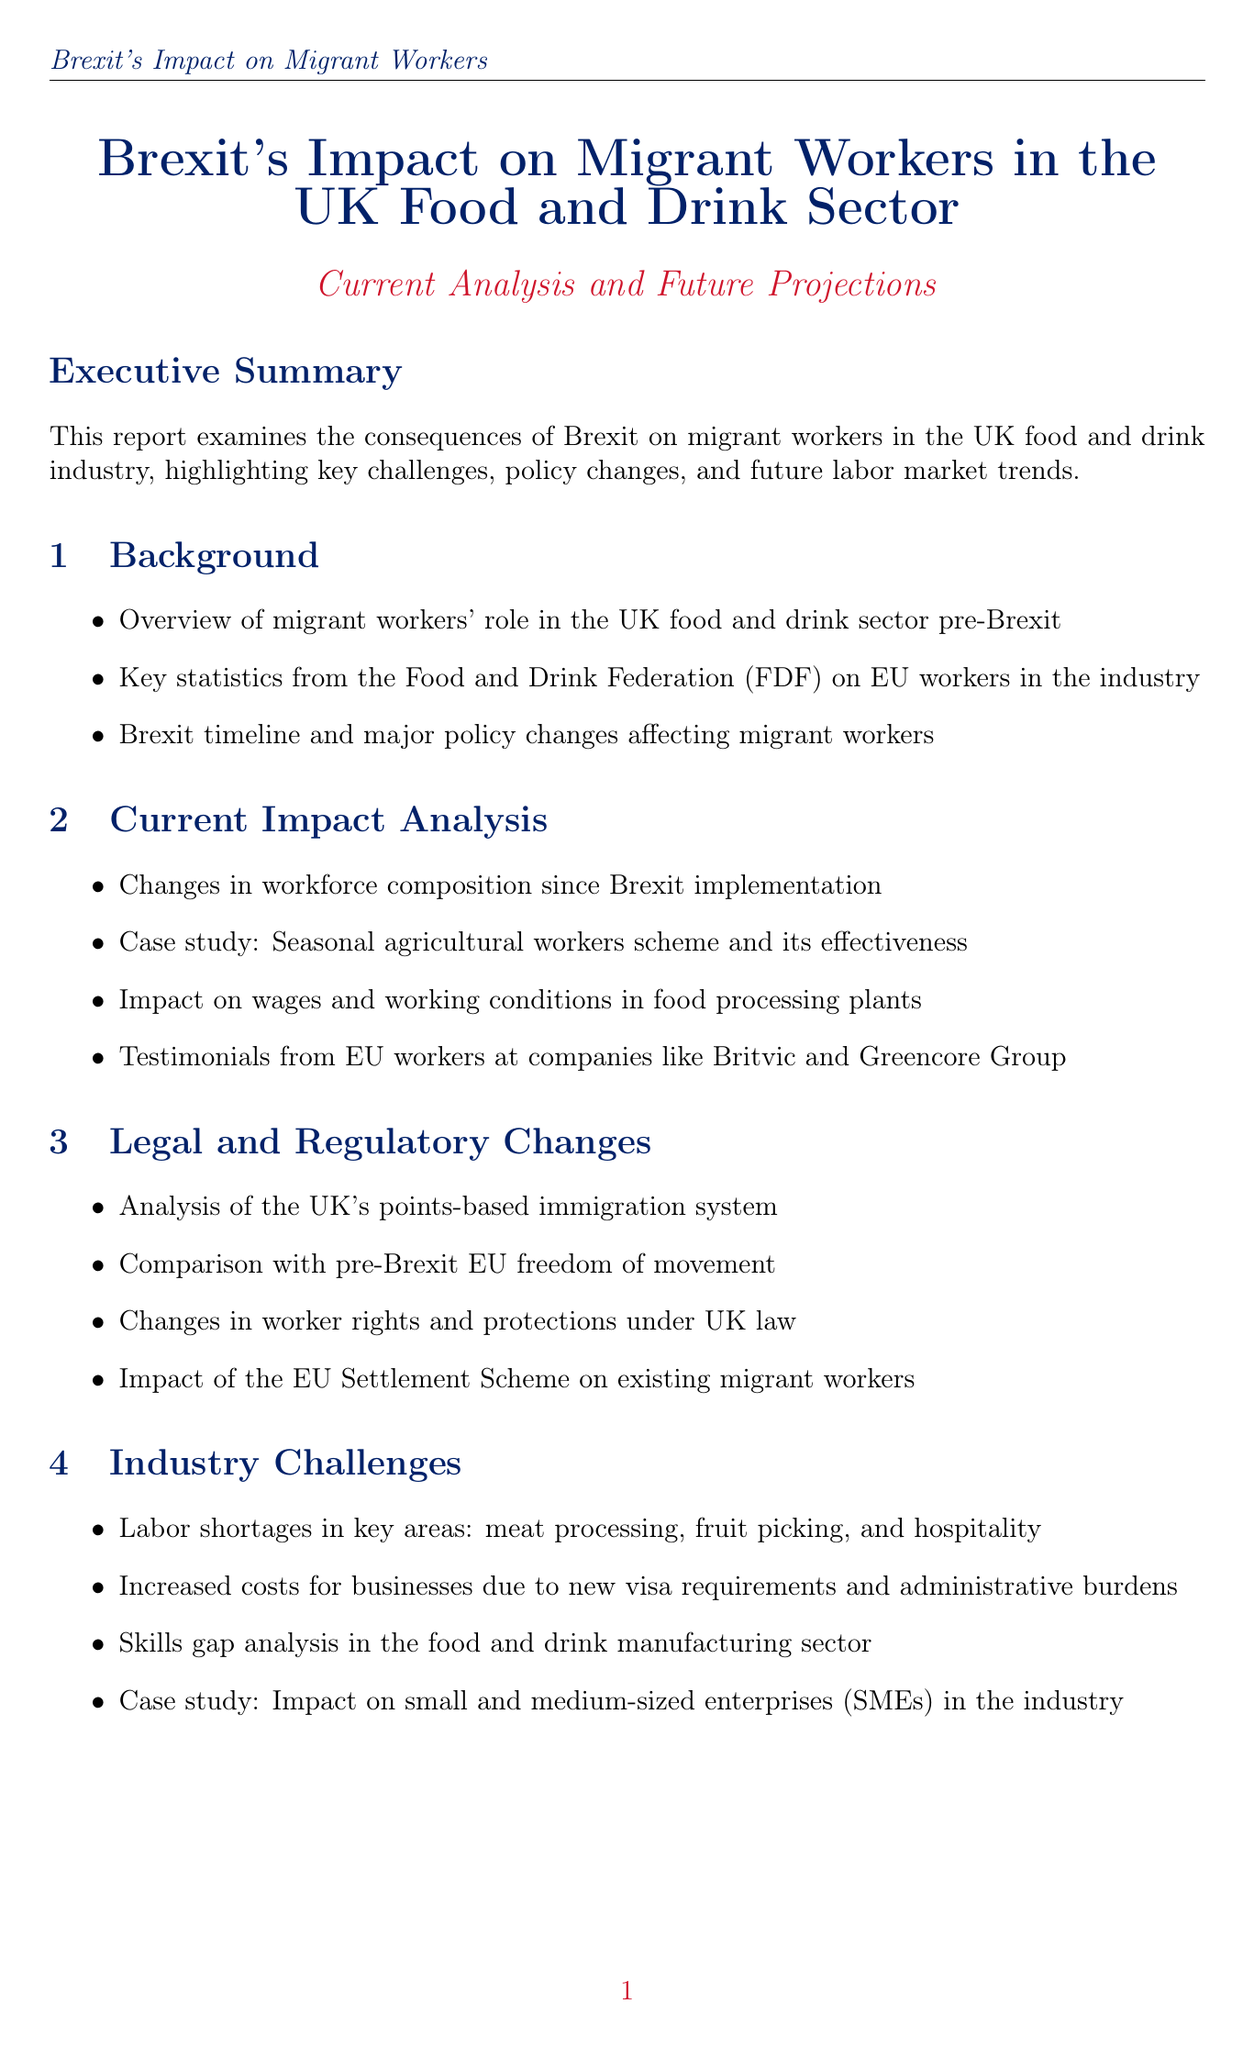what is the report title? The report title is the main heading of the document that indicates its subject matter.
Answer: Brexit's Impact on Migrant Workers in the UK Food and Drink Sector: Current Analysis and Future Projections what percentage of EU nationals were in the UK food and drink manufacturing workforce pre-Brexit? This statistic indicates the share of EU nationals in the workforce before the changes brought by Brexit.
Answer: 33% what is the decline in EU nationals working in the UK food and drink sector post-Brexit? This statistic shows the decrease in the number of EU nationals employed in the sector after Brexit occurred.
Answer: 26% how many vacancies are in the UK food and drink sector? This figure reveals the current number of job openings within the food and drink sector, which is essential for understanding labor shortages.
Answer: 500,000 who is the President of the National Farmers' Union? This individual's title and name are pertinent to understanding the leadership within the organization related to food and drink.
Answer: Minette Batters what are the key areas experiencing labor shortages in the industry? This question relates to understanding where the biggest gaps in the workforce are affecting industry operations.
Answer: meat processing, fruit picking, and hospitality what does the report suggest to address labor shortages? This inquiry explores the recommendations made in the report aimed at mitigating labor issues in the sector.
Answer: Policy suggestions to address labor shortages and protect workers' rights what is the short-term outlook for migrant workers in the sector? This question seeks to find the projections related to migrant worker employment shortly after Brexit.
Answer: Short-term (1-2 years) outlook for migrant workers in the sector 